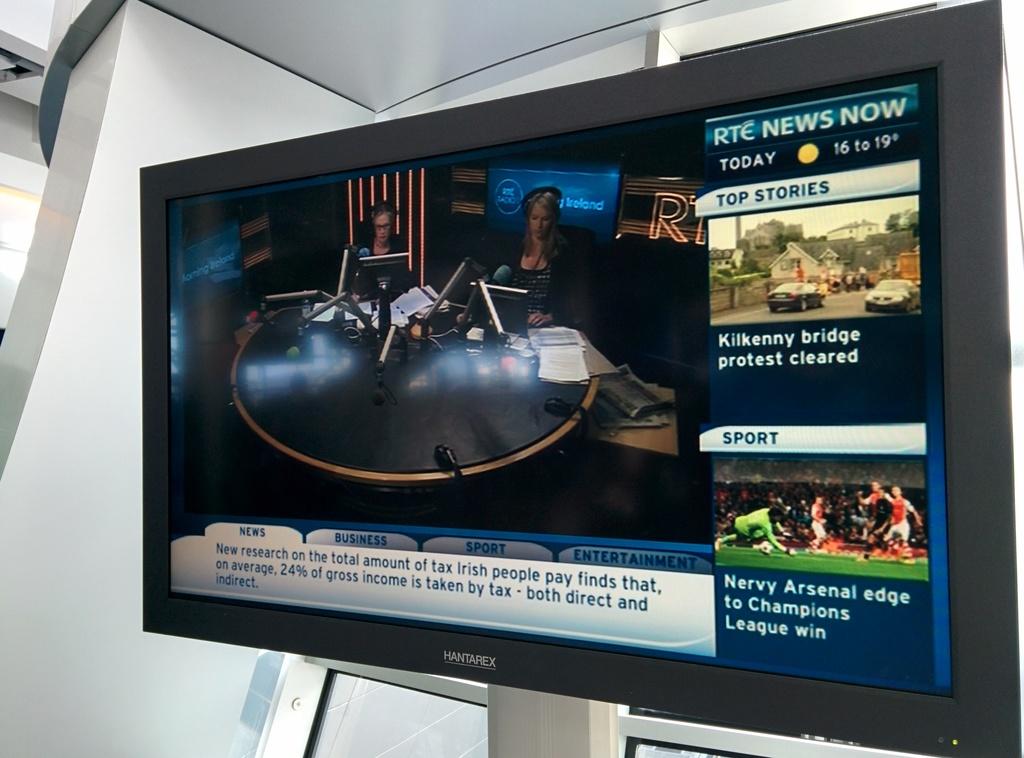What country is rte news from?
Provide a short and direct response. Unanswerable. 